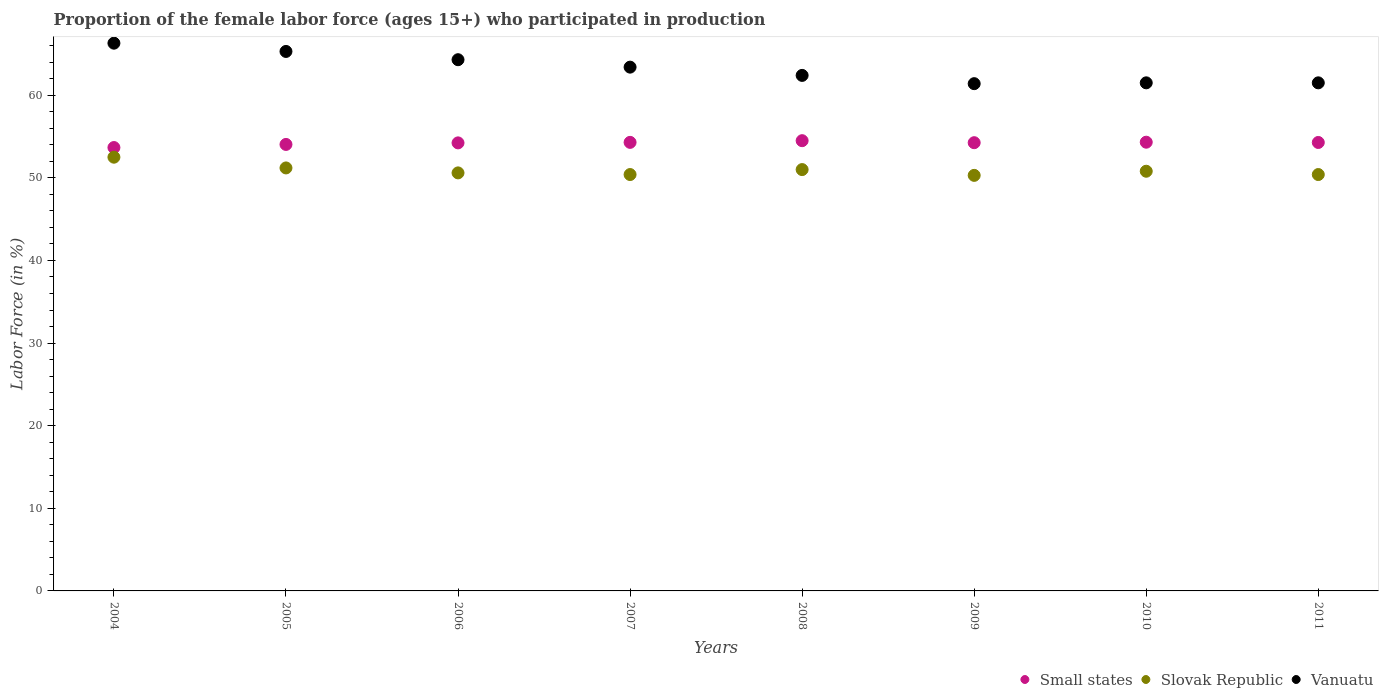Is the number of dotlines equal to the number of legend labels?
Give a very brief answer. Yes. What is the proportion of the female labor force who participated in production in Vanuatu in 2005?
Keep it short and to the point. 65.3. Across all years, what is the maximum proportion of the female labor force who participated in production in Small states?
Ensure brevity in your answer.  54.5. Across all years, what is the minimum proportion of the female labor force who participated in production in Slovak Republic?
Ensure brevity in your answer.  50.3. In which year was the proportion of the female labor force who participated in production in Vanuatu minimum?
Make the answer very short. 2009. What is the total proportion of the female labor force who participated in production in Small states in the graph?
Make the answer very short. 433.59. What is the difference between the proportion of the female labor force who participated in production in Slovak Republic in 2007 and that in 2008?
Make the answer very short. -0.6. What is the difference between the proportion of the female labor force who participated in production in Slovak Republic in 2007 and the proportion of the female labor force who participated in production in Vanuatu in 2010?
Give a very brief answer. -11.1. What is the average proportion of the female labor force who participated in production in Vanuatu per year?
Keep it short and to the point. 63.26. In the year 2007, what is the difference between the proportion of the female labor force who participated in production in Vanuatu and proportion of the female labor force who participated in production in Slovak Republic?
Offer a very short reply. 13. In how many years, is the proportion of the female labor force who participated in production in Vanuatu greater than 48 %?
Give a very brief answer. 8. What is the ratio of the proportion of the female labor force who participated in production in Small states in 2009 to that in 2011?
Your response must be concise. 1. Is the proportion of the female labor force who participated in production in Vanuatu in 2009 less than that in 2010?
Provide a short and direct response. Yes. What is the difference between the highest and the second highest proportion of the female labor force who participated in production in Vanuatu?
Ensure brevity in your answer.  1. What is the difference between the highest and the lowest proportion of the female labor force who participated in production in Vanuatu?
Your answer should be very brief. 4.9. In how many years, is the proportion of the female labor force who participated in production in Vanuatu greater than the average proportion of the female labor force who participated in production in Vanuatu taken over all years?
Offer a terse response. 4. Is it the case that in every year, the sum of the proportion of the female labor force who participated in production in Slovak Republic and proportion of the female labor force who participated in production in Small states  is greater than the proportion of the female labor force who participated in production in Vanuatu?
Your answer should be compact. Yes. Does the proportion of the female labor force who participated in production in Small states monotonically increase over the years?
Make the answer very short. No. Is the proportion of the female labor force who participated in production in Small states strictly less than the proportion of the female labor force who participated in production in Slovak Republic over the years?
Offer a terse response. No. How many dotlines are there?
Give a very brief answer. 3. How many years are there in the graph?
Your response must be concise. 8. What is the difference between two consecutive major ticks on the Y-axis?
Your answer should be compact. 10. Does the graph contain any zero values?
Make the answer very short. No. Does the graph contain grids?
Give a very brief answer. No. Where does the legend appear in the graph?
Offer a very short reply. Bottom right. How many legend labels are there?
Your answer should be compact. 3. What is the title of the graph?
Offer a very short reply. Proportion of the female labor force (ages 15+) who participated in production. What is the label or title of the X-axis?
Keep it short and to the point. Years. What is the Labor Force (in %) of Small states in 2004?
Offer a terse response. 53.67. What is the Labor Force (in %) in Slovak Republic in 2004?
Keep it short and to the point. 52.5. What is the Labor Force (in %) of Vanuatu in 2004?
Your answer should be very brief. 66.3. What is the Labor Force (in %) in Small states in 2005?
Your answer should be compact. 54.04. What is the Labor Force (in %) in Slovak Republic in 2005?
Ensure brevity in your answer.  51.2. What is the Labor Force (in %) of Vanuatu in 2005?
Your answer should be very brief. 65.3. What is the Labor Force (in %) of Small states in 2006?
Your answer should be compact. 54.23. What is the Labor Force (in %) of Slovak Republic in 2006?
Keep it short and to the point. 50.6. What is the Labor Force (in %) in Vanuatu in 2006?
Give a very brief answer. 64.3. What is the Labor Force (in %) of Small states in 2007?
Offer a terse response. 54.29. What is the Labor Force (in %) in Slovak Republic in 2007?
Make the answer very short. 50.4. What is the Labor Force (in %) in Vanuatu in 2007?
Keep it short and to the point. 63.4. What is the Labor Force (in %) in Small states in 2008?
Your answer should be very brief. 54.5. What is the Labor Force (in %) in Slovak Republic in 2008?
Offer a very short reply. 51. What is the Labor Force (in %) in Vanuatu in 2008?
Your answer should be very brief. 62.4. What is the Labor Force (in %) of Small states in 2009?
Your answer should be compact. 54.25. What is the Labor Force (in %) of Slovak Republic in 2009?
Your response must be concise. 50.3. What is the Labor Force (in %) of Vanuatu in 2009?
Offer a very short reply. 61.4. What is the Labor Force (in %) of Small states in 2010?
Provide a succinct answer. 54.31. What is the Labor Force (in %) of Slovak Republic in 2010?
Offer a very short reply. 50.8. What is the Labor Force (in %) of Vanuatu in 2010?
Keep it short and to the point. 61.5. What is the Labor Force (in %) of Small states in 2011?
Ensure brevity in your answer.  54.28. What is the Labor Force (in %) of Slovak Republic in 2011?
Offer a terse response. 50.4. What is the Labor Force (in %) in Vanuatu in 2011?
Give a very brief answer. 61.5. Across all years, what is the maximum Labor Force (in %) in Small states?
Your response must be concise. 54.5. Across all years, what is the maximum Labor Force (in %) in Slovak Republic?
Ensure brevity in your answer.  52.5. Across all years, what is the maximum Labor Force (in %) of Vanuatu?
Offer a terse response. 66.3. Across all years, what is the minimum Labor Force (in %) in Small states?
Your answer should be compact. 53.67. Across all years, what is the minimum Labor Force (in %) in Slovak Republic?
Provide a succinct answer. 50.3. Across all years, what is the minimum Labor Force (in %) of Vanuatu?
Give a very brief answer. 61.4. What is the total Labor Force (in %) of Small states in the graph?
Offer a terse response. 433.59. What is the total Labor Force (in %) in Slovak Republic in the graph?
Your response must be concise. 407.2. What is the total Labor Force (in %) of Vanuatu in the graph?
Your answer should be compact. 506.1. What is the difference between the Labor Force (in %) in Small states in 2004 and that in 2005?
Ensure brevity in your answer.  -0.38. What is the difference between the Labor Force (in %) in Vanuatu in 2004 and that in 2005?
Offer a terse response. 1. What is the difference between the Labor Force (in %) of Small states in 2004 and that in 2006?
Make the answer very short. -0.56. What is the difference between the Labor Force (in %) in Slovak Republic in 2004 and that in 2006?
Offer a very short reply. 1.9. What is the difference between the Labor Force (in %) of Small states in 2004 and that in 2007?
Provide a succinct answer. -0.63. What is the difference between the Labor Force (in %) of Slovak Republic in 2004 and that in 2007?
Provide a short and direct response. 2.1. What is the difference between the Labor Force (in %) of Small states in 2004 and that in 2008?
Ensure brevity in your answer.  -0.83. What is the difference between the Labor Force (in %) in Small states in 2004 and that in 2009?
Ensure brevity in your answer.  -0.59. What is the difference between the Labor Force (in %) of Slovak Republic in 2004 and that in 2009?
Your response must be concise. 2.2. What is the difference between the Labor Force (in %) of Small states in 2004 and that in 2010?
Ensure brevity in your answer.  -0.65. What is the difference between the Labor Force (in %) in Slovak Republic in 2004 and that in 2010?
Your answer should be compact. 1.7. What is the difference between the Labor Force (in %) of Small states in 2004 and that in 2011?
Provide a succinct answer. -0.61. What is the difference between the Labor Force (in %) in Slovak Republic in 2004 and that in 2011?
Make the answer very short. 2.1. What is the difference between the Labor Force (in %) of Vanuatu in 2004 and that in 2011?
Your response must be concise. 4.8. What is the difference between the Labor Force (in %) in Small states in 2005 and that in 2006?
Keep it short and to the point. -0.19. What is the difference between the Labor Force (in %) in Slovak Republic in 2005 and that in 2006?
Your answer should be very brief. 0.6. What is the difference between the Labor Force (in %) in Small states in 2005 and that in 2007?
Offer a very short reply. -0.25. What is the difference between the Labor Force (in %) in Small states in 2005 and that in 2008?
Give a very brief answer. -0.45. What is the difference between the Labor Force (in %) in Slovak Republic in 2005 and that in 2008?
Your response must be concise. 0.2. What is the difference between the Labor Force (in %) in Small states in 2005 and that in 2009?
Ensure brevity in your answer.  -0.21. What is the difference between the Labor Force (in %) in Vanuatu in 2005 and that in 2009?
Your answer should be compact. 3.9. What is the difference between the Labor Force (in %) of Small states in 2005 and that in 2010?
Provide a succinct answer. -0.27. What is the difference between the Labor Force (in %) of Small states in 2005 and that in 2011?
Offer a very short reply. -0.24. What is the difference between the Labor Force (in %) of Vanuatu in 2005 and that in 2011?
Offer a terse response. 3.8. What is the difference between the Labor Force (in %) in Small states in 2006 and that in 2007?
Your answer should be very brief. -0.06. What is the difference between the Labor Force (in %) in Slovak Republic in 2006 and that in 2007?
Keep it short and to the point. 0.2. What is the difference between the Labor Force (in %) of Small states in 2006 and that in 2008?
Provide a succinct answer. -0.27. What is the difference between the Labor Force (in %) of Slovak Republic in 2006 and that in 2008?
Ensure brevity in your answer.  -0.4. What is the difference between the Labor Force (in %) in Vanuatu in 2006 and that in 2008?
Your response must be concise. 1.9. What is the difference between the Labor Force (in %) of Small states in 2006 and that in 2009?
Provide a short and direct response. -0.02. What is the difference between the Labor Force (in %) in Vanuatu in 2006 and that in 2009?
Offer a very short reply. 2.9. What is the difference between the Labor Force (in %) of Small states in 2006 and that in 2010?
Provide a succinct answer. -0.08. What is the difference between the Labor Force (in %) in Slovak Republic in 2006 and that in 2010?
Provide a short and direct response. -0.2. What is the difference between the Labor Force (in %) of Small states in 2006 and that in 2011?
Make the answer very short. -0.05. What is the difference between the Labor Force (in %) of Slovak Republic in 2006 and that in 2011?
Ensure brevity in your answer.  0.2. What is the difference between the Labor Force (in %) in Small states in 2007 and that in 2008?
Your answer should be compact. -0.2. What is the difference between the Labor Force (in %) in Slovak Republic in 2007 and that in 2008?
Your answer should be very brief. -0.6. What is the difference between the Labor Force (in %) in Vanuatu in 2007 and that in 2008?
Make the answer very short. 1. What is the difference between the Labor Force (in %) in Slovak Republic in 2007 and that in 2009?
Offer a terse response. 0.1. What is the difference between the Labor Force (in %) of Vanuatu in 2007 and that in 2009?
Make the answer very short. 2. What is the difference between the Labor Force (in %) in Small states in 2007 and that in 2010?
Provide a short and direct response. -0.02. What is the difference between the Labor Force (in %) in Slovak Republic in 2007 and that in 2010?
Provide a succinct answer. -0.4. What is the difference between the Labor Force (in %) of Small states in 2007 and that in 2011?
Your answer should be very brief. 0.01. What is the difference between the Labor Force (in %) in Vanuatu in 2007 and that in 2011?
Give a very brief answer. 1.9. What is the difference between the Labor Force (in %) in Small states in 2008 and that in 2009?
Make the answer very short. 0.24. What is the difference between the Labor Force (in %) of Slovak Republic in 2008 and that in 2009?
Make the answer very short. 0.7. What is the difference between the Labor Force (in %) in Small states in 2008 and that in 2010?
Make the answer very short. 0.18. What is the difference between the Labor Force (in %) in Small states in 2008 and that in 2011?
Your answer should be compact. 0.22. What is the difference between the Labor Force (in %) of Vanuatu in 2008 and that in 2011?
Make the answer very short. 0.9. What is the difference between the Labor Force (in %) of Small states in 2009 and that in 2010?
Your response must be concise. -0.06. What is the difference between the Labor Force (in %) in Small states in 2009 and that in 2011?
Offer a very short reply. -0.03. What is the difference between the Labor Force (in %) in Small states in 2010 and that in 2011?
Keep it short and to the point. 0.03. What is the difference between the Labor Force (in %) in Vanuatu in 2010 and that in 2011?
Your answer should be compact. 0. What is the difference between the Labor Force (in %) in Small states in 2004 and the Labor Force (in %) in Slovak Republic in 2005?
Offer a terse response. 2.47. What is the difference between the Labor Force (in %) of Small states in 2004 and the Labor Force (in %) of Vanuatu in 2005?
Provide a short and direct response. -11.63. What is the difference between the Labor Force (in %) of Small states in 2004 and the Labor Force (in %) of Slovak Republic in 2006?
Provide a succinct answer. 3.07. What is the difference between the Labor Force (in %) of Small states in 2004 and the Labor Force (in %) of Vanuatu in 2006?
Make the answer very short. -10.63. What is the difference between the Labor Force (in %) of Small states in 2004 and the Labor Force (in %) of Slovak Republic in 2007?
Give a very brief answer. 3.27. What is the difference between the Labor Force (in %) in Small states in 2004 and the Labor Force (in %) in Vanuatu in 2007?
Your answer should be compact. -9.73. What is the difference between the Labor Force (in %) of Small states in 2004 and the Labor Force (in %) of Slovak Republic in 2008?
Your answer should be very brief. 2.67. What is the difference between the Labor Force (in %) of Small states in 2004 and the Labor Force (in %) of Vanuatu in 2008?
Your answer should be compact. -8.73. What is the difference between the Labor Force (in %) in Slovak Republic in 2004 and the Labor Force (in %) in Vanuatu in 2008?
Provide a short and direct response. -9.9. What is the difference between the Labor Force (in %) of Small states in 2004 and the Labor Force (in %) of Slovak Republic in 2009?
Give a very brief answer. 3.37. What is the difference between the Labor Force (in %) of Small states in 2004 and the Labor Force (in %) of Vanuatu in 2009?
Offer a terse response. -7.73. What is the difference between the Labor Force (in %) in Slovak Republic in 2004 and the Labor Force (in %) in Vanuatu in 2009?
Your answer should be very brief. -8.9. What is the difference between the Labor Force (in %) of Small states in 2004 and the Labor Force (in %) of Slovak Republic in 2010?
Make the answer very short. 2.87. What is the difference between the Labor Force (in %) in Small states in 2004 and the Labor Force (in %) in Vanuatu in 2010?
Make the answer very short. -7.83. What is the difference between the Labor Force (in %) of Small states in 2004 and the Labor Force (in %) of Slovak Republic in 2011?
Your answer should be compact. 3.27. What is the difference between the Labor Force (in %) of Small states in 2004 and the Labor Force (in %) of Vanuatu in 2011?
Offer a very short reply. -7.83. What is the difference between the Labor Force (in %) of Slovak Republic in 2004 and the Labor Force (in %) of Vanuatu in 2011?
Offer a terse response. -9. What is the difference between the Labor Force (in %) in Small states in 2005 and the Labor Force (in %) in Slovak Republic in 2006?
Offer a terse response. 3.44. What is the difference between the Labor Force (in %) of Small states in 2005 and the Labor Force (in %) of Vanuatu in 2006?
Your answer should be compact. -10.26. What is the difference between the Labor Force (in %) in Slovak Republic in 2005 and the Labor Force (in %) in Vanuatu in 2006?
Your answer should be compact. -13.1. What is the difference between the Labor Force (in %) of Small states in 2005 and the Labor Force (in %) of Slovak Republic in 2007?
Give a very brief answer. 3.64. What is the difference between the Labor Force (in %) of Small states in 2005 and the Labor Force (in %) of Vanuatu in 2007?
Your answer should be very brief. -9.36. What is the difference between the Labor Force (in %) in Small states in 2005 and the Labor Force (in %) in Slovak Republic in 2008?
Your answer should be very brief. 3.04. What is the difference between the Labor Force (in %) in Small states in 2005 and the Labor Force (in %) in Vanuatu in 2008?
Provide a short and direct response. -8.36. What is the difference between the Labor Force (in %) in Slovak Republic in 2005 and the Labor Force (in %) in Vanuatu in 2008?
Ensure brevity in your answer.  -11.2. What is the difference between the Labor Force (in %) of Small states in 2005 and the Labor Force (in %) of Slovak Republic in 2009?
Your response must be concise. 3.74. What is the difference between the Labor Force (in %) in Small states in 2005 and the Labor Force (in %) in Vanuatu in 2009?
Offer a terse response. -7.36. What is the difference between the Labor Force (in %) in Small states in 2005 and the Labor Force (in %) in Slovak Republic in 2010?
Ensure brevity in your answer.  3.24. What is the difference between the Labor Force (in %) of Small states in 2005 and the Labor Force (in %) of Vanuatu in 2010?
Offer a very short reply. -7.46. What is the difference between the Labor Force (in %) of Slovak Republic in 2005 and the Labor Force (in %) of Vanuatu in 2010?
Your response must be concise. -10.3. What is the difference between the Labor Force (in %) in Small states in 2005 and the Labor Force (in %) in Slovak Republic in 2011?
Make the answer very short. 3.64. What is the difference between the Labor Force (in %) of Small states in 2005 and the Labor Force (in %) of Vanuatu in 2011?
Offer a terse response. -7.46. What is the difference between the Labor Force (in %) in Small states in 2006 and the Labor Force (in %) in Slovak Republic in 2007?
Your answer should be compact. 3.83. What is the difference between the Labor Force (in %) of Small states in 2006 and the Labor Force (in %) of Vanuatu in 2007?
Provide a succinct answer. -9.17. What is the difference between the Labor Force (in %) in Small states in 2006 and the Labor Force (in %) in Slovak Republic in 2008?
Keep it short and to the point. 3.23. What is the difference between the Labor Force (in %) of Small states in 2006 and the Labor Force (in %) of Vanuatu in 2008?
Make the answer very short. -8.17. What is the difference between the Labor Force (in %) of Slovak Republic in 2006 and the Labor Force (in %) of Vanuatu in 2008?
Your response must be concise. -11.8. What is the difference between the Labor Force (in %) in Small states in 2006 and the Labor Force (in %) in Slovak Republic in 2009?
Make the answer very short. 3.93. What is the difference between the Labor Force (in %) of Small states in 2006 and the Labor Force (in %) of Vanuatu in 2009?
Provide a succinct answer. -7.17. What is the difference between the Labor Force (in %) in Small states in 2006 and the Labor Force (in %) in Slovak Republic in 2010?
Your answer should be compact. 3.43. What is the difference between the Labor Force (in %) in Small states in 2006 and the Labor Force (in %) in Vanuatu in 2010?
Offer a very short reply. -7.27. What is the difference between the Labor Force (in %) in Slovak Republic in 2006 and the Labor Force (in %) in Vanuatu in 2010?
Offer a terse response. -10.9. What is the difference between the Labor Force (in %) in Small states in 2006 and the Labor Force (in %) in Slovak Republic in 2011?
Keep it short and to the point. 3.83. What is the difference between the Labor Force (in %) of Small states in 2006 and the Labor Force (in %) of Vanuatu in 2011?
Provide a short and direct response. -7.27. What is the difference between the Labor Force (in %) of Slovak Republic in 2006 and the Labor Force (in %) of Vanuatu in 2011?
Your answer should be very brief. -10.9. What is the difference between the Labor Force (in %) in Small states in 2007 and the Labor Force (in %) in Slovak Republic in 2008?
Your answer should be very brief. 3.29. What is the difference between the Labor Force (in %) in Small states in 2007 and the Labor Force (in %) in Vanuatu in 2008?
Your answer should be very brief. -8.11. What is the difference between the Labor Force (in %) of Slovak Republic in 2007 and the Labor Force (in %) of Vanuatu in 2008?
Your answer should be compact. -12. What is the difference between the Labor Force (in %) of Small states in 2007 and the Labor Force (in %) of Slovak Republic in 2009?
Make the answer very short. 3.99. What is the difference between the Labor Force (in %) of Small states in 2007 and the Labor Force (in %) of Vanuatu in 2009?
Offer a very short reply. -7.11. What is the difference between the Labor Force (in %) of Slovak Republic in 2007 and the Labor Force (in %) of Vanuatu in 2009?
Your answer should be very brief. -11. What is the difference between the Labor Force (in %) in Small states in 2007 and the Labor Force (in %) in Slovak Republic in 2010?
Your answer should be very brief. 3.49. What is the difference between the Labor Force (in %) in Small states in 2007 and the Labor Force (in %) in Vanuatu in 2010?
Make the answer very short. -7.21. What is the difference between the Labor Force (in %) in Slovak Republic in 2007 and the Labor Force (in %) in Vanuatu in 2010?
Keep it short and to the point. -11.1. What is the difference between the Labor Force (in %) in Small states in 2007 and the Labor Force (in %) in Slovak Republic in 2011?
Make the answer very short. 3.89. What is the difference between the Labor Force (in %) of Small states in 2007 and the Labor Force (in %) of Vanuatu in 2011?
Make the answer very short. -7.21. What is the difference between the Labor Force (in %) of Slovak Republic in 2007 and the Labor Force (in %) of Vanuatu in 2011?
Offer a terse response. -11.1. What is the difference between the Labor Force (in %) in Small states in 2008 and the Labor Force (in %) in Slovak Republic in 2009?
Offer a terse response. 4.2. What is the difference between the Labor Force (in %) in Small states in 2008 and the Labor Force (in %) in Vanuatu in 2009?
Provide a short and direct response. -6.9. What is the difference between the Labor Force (in %) in Small states in 2008 and the Labor Force (in %) in Slovak Republic in 2010?
Your answer should be compact. 3.7. What is the difference between the Labor Force (in %) in Small states in 2008 and the Labor Force (in %) in Vanuatu in 2010?
Your answer should be very brief. -7. What is the difference between the Labor Force (in %) of Slovak Republic in 2008 and the Labor Force (in %) of Vanuatu in 2010?
Your response must be concise. -10.5. What is the difference between the Labor Force (in %) of Small states in 2008 and the Labor Force (in %) of Slovak Republic in 2011?
Ensure brevity in your answer.  4.1. What is the difference between the Labor Force (in %) of Small states in 2008 and the Labor Force (in %) of Vanuatu in 2011?
Offer a very short reply. -7. What is the difference between the Labor Force (in %) of Slovak Republic in 2008 and the Labor Force (in %) of Vanuatu in 2011?
Keep it short and to the point. -10.5. What is the difference between the Labor Force (in %) in Small states in 2009 and the Labor Force (in %) in Slovak Republic in 2010?
Provide a succinct answer. 3.45. What is the difference between the Labor Force (in %) in Small states in 2009 and the Labor Force (in %) in Vanuatu in 2010?
Your response must be concise. -7.25. What is the difference between the Labor Force (in %) in Slovak Republic in 2009 and the Labor Force (in %) in Vanuatu in 2010?
Keep it short and to the point. -11.2. What is the difference between the Labor Force (in %) of Small states in 2009 and the Labor Force (in %) of Slovak Republic in 2011?
Ensure brevity in your answer.  3.85. What is the difference between the Labor Force (in %) of Small states in 2009 and the Labor Force (in %) of Vanuatu in 2011?
Keep it short and to the point. -7.25. What is the difference between the Labor Force (in %) in Small states in 2010 and the Labor Force (in %) in Slovak Republic in 2011?
Provide a succinct answer. 3.91. What is the difference between the Labor Force (in %) of Small states in 2010 and the Labor Force (in %) of Vanuatu in 2011?
Provide a succinct answer. -7.19. What is the difference between the Labor Force (in %) in Slovak Republic in 2010 and the Labor Force (in %) in Vanuatu in 2011?
Provide a short and direct response. -10.7. What is the average Labor Force (in %) in Small states per year?
Provide a short and direct response. 54.2. What is the average Labor Force (in %) in Slovak Republic per year?
Your answer should be very brief. 50.9. What is the average Labor Force (in %) of Vanuatu per year?
Ensure brevity in your answer.  63.26. In the year 2004, what is the difference between the Labor Force (in %) in Small states and Labor Force (in %) in Slovak Republic?
Offer a very short reply. 1.17. In the year 2004, what is the difference between the Labor Force (in %) of Small states and Labor Force (in %) of Vanuatu?
Provide a short and direct response. -12.63. In the year 2004, what is the difference between the Labor Force (in %) of Slovak Republic and Labor Force (in %) of Vanuatu?
Provide a succinct answer. -13.8. In the year 2005, what is the difference between the Labor Force (in %) in Small states and Labor Force (in %) in Slovak Republic?
Your answer should be very brief. 2.84. In the year 2005, what is the difference between the Labor Force (in %) of Small states and Labor Force (in %) of Vanuatu?
Ensure brevity in your answer.  -11.26. In the year 2005, what is the difference between the Labor Force (in %) of Slovak Republic and Labor Force (in %) of Vanuatu?
Offer a terse response. -14.1. In the year 2006, what is the difference between the Labor Force (in %) in Small states and Labor Force (in %) in Slovak Republic?
Your response must be concise. 3.63. In the year 2006, what is the difference between the Labor Force (in %) in Small states and Labor Force (in %) in Vanuatu?
Your answer should be very brief. -10.07. In the year 2006, what is the difference between the Labor Force (in %) in Slovak Republic and Labor Force (in %) in Vanuatu?
Offer a terse response. -13.7. In the year 2007, what is the difference between the Labor Force (in %) in Small states and Labor Force (in %) in Slovak Republic?
Make the answer very short. 3.89. In the year 2007, what is the difference between the Labor Force (in %) in Small states and Labor Force (in %) in Vanuatu?
Offer a very short reply. -9.11. In the year 2007, what is the difference between the Labor Force (in %) in Slovak Republic and Labor Force (in %) in Vanuatu?
Your answer should be very brief. -13. In the year 2008, what is the difference between the Labor Force (in %) in Small states and Labor Force (in %) in Slovak Republic?
Your answer should be very brief. 3.5. In the year 2008, what is the difference between the Labor Force (in %) of Small states and Labor Force (in %) of Vanuatu?
Offer a terse response. -7.9. In the year 2009, what is the difference between the Labor Force (in %) of Small states and Labor Force (in %) of Slovak Republic?
Give a very brief answer. 3.95. In the year 2009, what is the difference between the Labor Force (in %) in Small states and Labor Force (in %) in Vanuatu?
Give a very brief answer. -7.15. In the year 2010, what is the difference between the Labor Force (in %) in Small states and Labor Force (in %) in Slovak Republic?
Your answer should be compact. 3.51. In the year 2010, what is the difference between the Labor Force (in %) in Small states and Labor Force (in %) in Vanuatu?
Offer a terse response. -7.19. In the year 2011, what is the difference between the Labor Force (in %) in Small states and Labor Force (in %) in Slovak Republic?
Give a very brief answer. 3.88. In the year 2011, what is the difference between the Labor Force (in %) in Small states and Labor Force (in %) in Vanuatu?
Keep it short and to the point. -7.22. What is the ratio of the Labor Force (in %) in Small states in 2004 to that in 2005?
Provide a succinct answer. 0.99. What is the ratio of the Labor Force (in %) in Slovak Republic in 2004 to that in 2005?
Keep it short and to the point. 1.03. What is the ratio of the Labor Force (in %) in Vanuatu in 2004 to that in 2005?
Your answer should be very brief. 1.02. What is the ratio of the Labor Force (in %) in Small states in 2004 to that in 2006?
Give a very brief answer. 0.99. What is the ratio of the Labor Force (in %) of Slovak Republic in 2004 to that in 2006?
Your answer should be compact. 1.04. What is the ratio of the Labor Force (in %) in Vanuatu in 2004 to that in 2006?
Provide a succinct answer. 1.03. What is the ratio of the Labor Force (in %) of Small states in 2004 to that in 2007?
Give a very brief answer. 0.99. What is the ratio of the Labor Force (in %) of Slovak Republic in 2004 to that in 2007?
Give a very brief answer. 1.04. What is the ratio of the Labor Force (in %) in Vanuatu in 2004 to that in 2007?
Your answer should be very brief. 1.05. What is the ratio of the Labor Force (in %) of Small states in 2004 to that in 2008?
Keep it short and to the point. 0.98. What is the ratio of the Labor Force (in %) in Slovak Republic in 2004 to that in 2008?
Offer a very short reply. 1.03. What is the ratio of the Labor Force (in %) in Vanuatu in 2004 to that in 2008?
Make the answer very short. 1.06. What is the ratio of the Labor Force (in %) in Small states in 2004 to that in 2009?
Provide a succinct answer. 0.99. What is the ratio of the Labor Force (in %) in Slovak Republic in 2004 to that in 2009?
Offer a terse response. 1.04. What is the ratio of the Labor Force (in %) in Vanuatu in 2004 to that in 2009?
Provide a succinct answer. 1.08. What is the ratio of the Labor Force (in %) of Slovak Republic in 2004 to that in 2010?
Offer a terse response. 1.03. What is the ratio of the Labor Force (in %) of Vanuatu in 2004 to that in 2010?
Your response must be concise. 1.08. What is the ratio of the Labor Force (in %) of Small states in 2004 to that in 2011?
Provide a short and direct response. 0.99. What is the ratio of the Labor Force (in %) of Slovak Republic in 2004 to that in 2011?
Your response must be concise. 1.04. What is the ratio of the Labor Force (in %) in Vanuatu in 2004 to that in 2011?
Keep it short and to the point. 1.08. What is the ratio of the Labor Force (in %) of Small states in 2005 to that in 2006?
Your answer should be very brief. 1. What is the ratio of the Labor Force (in %) of Slovak Republic in 2005 to that in 2006?
Provide a short and direct response. 1.01. What is the ratio of the Labor Force (in %) of Vanuatu in 2005 to that in 2006?
Offer a terse response. 1.02. What is the ratio of the Labor Force (in %) in Slovak Republic in 2005 to that in 2007?
Provide a short and direct response. 1.02. What is the ratio of the Labor Force (in %) in Vanuatu in 2005 to that in 2008?
Ensure brevity in your answer.  1.05. What is the ratio of the Labor Force (in %) in Small states in 2005 to that in 2009?
Provide a short and direct response. 1. What is the ratio of the Labor Force (in %) of Slovak Republic in 2005 to that in 2009?
Provide a succinct answer. 1.02. What is the ratio of the Labor Force (in %) in Vanuatu in 2005 to that in 2009?
Ensure brevity in your answer.  1.06. What is the ratio of the Labor Force (in %) in Slovak Republic in 2005 to that in 2010?
Offer a very short reply. 1.01. What is the ratio of the Labor Force (in %) in Vanuatu in 2005 to that in 2010?
Keep it short and to the point. 1.06. What is the ratio of the Labor Force (in %) in Slovak Republic in 2005 to that in 2011?
Provide a short and direct response. 1.02. What is the ratio of the Labor Force (in %) in Vanuatu in 2005 to that in 2011?
Your answer should be very brief. 1.06. What is the ratio of the Labor Force (in %) in Small states in 2006 to that in 2007?
Offer a terse response. 1. What is the ratio of the Labor Force (in %) in Vanuatu in 2006 to that in 2007?
Give a very brief answer. 1.01. What is the ratio of the Labor Force (in %) of Vanuatu in 2006 to that in 2008?
Give a very brief answer. 1.03. What is the ratio of the Labor Force (in %) of Slovak Republic in 2006 to that in 2009?
Make the answer very short. 1.01. What is the ratio of the Labor Force (in %) in Vanuatu in 2006 to that in 2009?
Your response must be concise. 1.05. What is the ratio of the Labor Force (in %) of Vanuatu in 2006 to that in 2010?
Your response must be concise. 1.05. What is the ratio of the Labor Force (in %) of Small states in 2006 to that in 2011?
Offer a terse response. 1. What is the ratio of the Labor Force (in %) of Slovak Republic in 2006 to that in 2011?
Offer a terse response. 1. What is the ratio of the Labor Force (in %) in Vanuatu in 2006 to that in 2011?
Provide a succinct answer. 1.05. What is the ratio of the Labor Force (in %) in Small states in 2007 to that in 2008?
Ensure brevity in your answer.  1. What is the ratio of the Labor Force (in %) in Slovak Republic in 2007 to that in 2008?
Your answer should be very brief. 0.99. What is the ratio of the Labor Force (in %) in Vanuatu in 2007 to that in 2008?
Your response must be concise. 1.02. What is the ratio of the Labor Force (in %) in Small states in 2007 to that in 2009?
Offer a very short reply. 1. What is the ratio of the Labor Force (in %) in Vanuatu in 2007 to that in 2009?
Make the answer very short. 1.03. What is the ratio of the Labor Force (in %) of Vanuatu in 2007 to that in 2010?
Provide a short and direct response. 1.03. What is the ratio of the Labor Force (in %) of Slovak Republic in 2007 to that in 2011?
Provide a succinct answer. 1. What is the ratio of the Labor Force (in %) in Vanuatu in 2007 to that in 2011?
Provide a short and direct response. 1.03. What is the ratio of the Labor Force (in %) in Small states in 2008 to that in 2009?
Ensure brevity in your answer.  1. What is the ratio of the Labor Force (in %) in Slovak Republic in 2008 to that in 2009?
Make the answer very short. 1.01. What is the ratio of the Labor Force (in %) of Vanuatu in 2008 to that in 2009?
Provide a succinct answer. 1.02. What is the ratio of the Labor Force (in %) of Small states in 2008 to that in 2010?
Keep it short and to the point. 1. What is the ratio of the Labor Force (in %) in Vanuatu in 2008 to that in 2010?
Give a very brief answer. 1.01. What is the ratio of the Labor Force (in %) of Small states in 2008 to that in 2011?
Your answer should be compact. 1. What is the ratio of the Labor Force (in %) in Slovak Republic in 2008 to that in 2011?
Offer a very short reply. 1.01. What is the ratio of the Labor Force (in %) in Vanuatu in 2008 to that in 2011?
Your answer should be compact. 1.01. What is the ratio of the Labor Force (in %) in Slovak Republic in 2009 to that in 2010?
Your answer should be compact. 0.99. What is the ratio of the Labor Force (in %) of Vanuatu in 2009 to that in 2011?
Make the answer very short. 1. What is the ratio of the Labor Force (in %) of Small states in 2010 to that in 2011?
Give a very brief answer. 1. What is the ratio of the Labor Force (in %) of Slovak Republic in 2010 to that in 2011?
Offer a very short reply. 1.01. What is the difference between the highest and the second highest Labor Force (in %) of Small states?
Offer a terse response. 0.18. What is the difference between the highest and the lowest Labor Force (in %) in Small states?
Your answer should be very brief. 0.83. What is the difference between the highest and the lowest Labor Force (in %) in Vanuatu?
Ensure brevity in your answer.  4.9. 